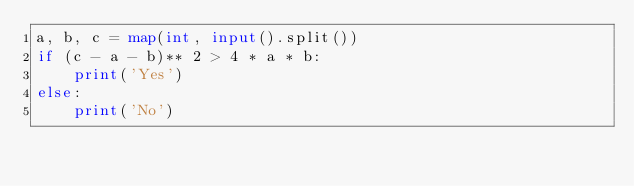Convert code to text. <code><loc_0><loc_0><loc_500><loc_500><_Python_>a, b, c = map(int, input().split())
if (c - a - b)** 2 > 4 * a * b:
    print('Yes')
else:
    print('No')</code> 